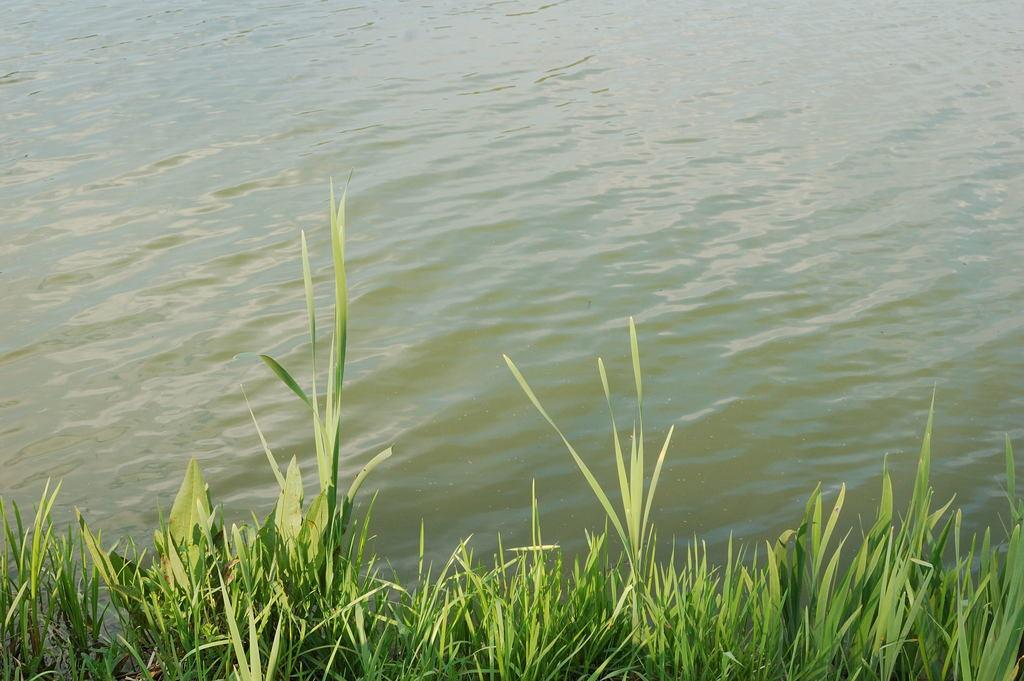What type of living organisms can be seen in the image? Plants can be seen in the image. What is the primary element visible in the image? Water is visible in the image. What type of lumber is being used to support the plants in the image? There is no lumber present in the image; it only features plants and water. 